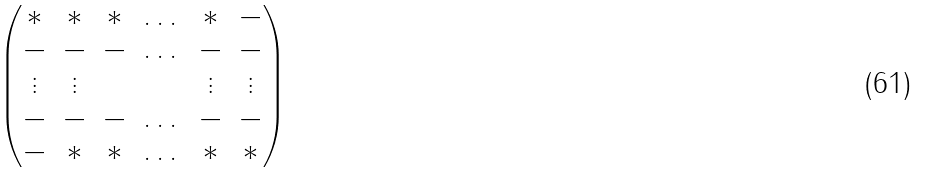Convert formula to latex. <formula><loc_0><loc_0><loc_500><loc_500>\begin{pmatrix} * & * & * & \dots & * & - \\ - & - & - & \dots & - & - \\ \vdots & \vdots & & & \vdots & \vdots \\ - & - & - & \dots & - & - \\ - & * & * & \dots & * & * \end{pmatrix}</formula> 